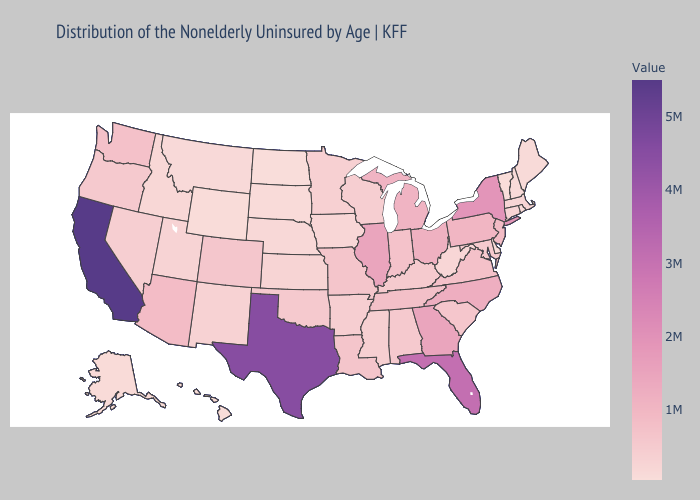Which states have the lowest value in the USA?
Give a very brief answer. Vermont. Does North Carolina have the highest value in the USA?
Write a very short answer. No. Which states have the highest value in the USA?
Quick response, please. California. Among the states that border Minnesota , does Wisconsin have the highest value?
Answer briefly. Yes. Among the states that border Missouri , does Nebraska have the lowest value?
Write a very short answer. Yes. Which states have the lowest value in the USA?
Quick response, please. Vermont. 